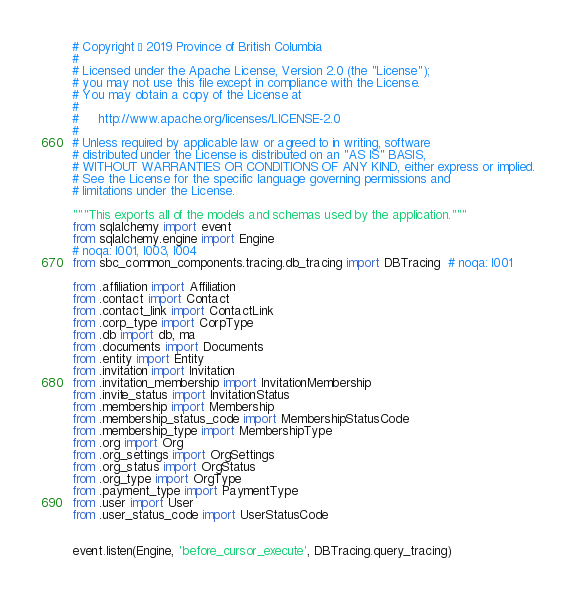<code> <loc_0><loc_0><loc_500><loc_500><_Python_># Copyright © 2019 Province of British Columbia
#
# Licensed under the Apache License, Version 2.0 (the "License");
# you may not use this file except in compliance with the License.
# You may obtain a copy of the License at
#
#     http://www.apache.org/licenses/LICENSE-2.0
#
# Unless required by applicable law or agreed to in writing, software
# distributed under the License is distributed on an "AS IS" BASIS,
# WITHOUT WARRANTIES OR CONDITIONS OF ANY KIND, either express or implied.
# See the License for the specific language governing permissions and
# limitations under the License.

"""This exports all of the models and schemas used by the application."""
from sqlalchemy import event
from sqlalchemy.engine import Engine
# noqa: I001, I003, I004
from sbc_common_components.tracing.db_tracing import DBTracing  # noqa: I001

from .affiliation import Affiliation
from .contact import Contact
from .contact_link import ContactLink
from .corp_type import CorpType
from .db import db, ma
from .documents import Documents
from .entity import Entity
from .invitation import Invitation
from .invitation_membership import InvitationMembership
from .invite_status import InvitationStatus
from .membership import Membership
from .membership_status_code import MembershipStatusCode
from .membership_type import MembershipType
from .org import Org
from .org_settings import OrgSettings
from .org_status import OrgStatus
from .org_type import OrgType
from .payment_type import PaymentType
from .user import User
from .user_status_code import UserStatusCode


event.listen(Engine, 'before_cursor_execute', DBTracing.query_tracing)
</code> 